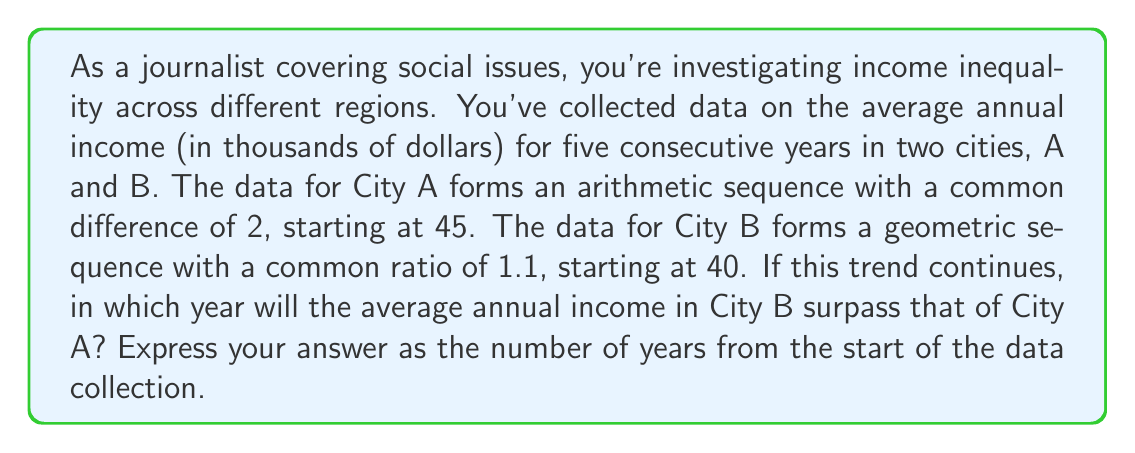Teach me how to tackle this problem. Let's approach this step-by-step:

1) For City A (arithmetic sequence):
   $a_n = a_1 + (n-1)d$, where $a_1 = 45$ and $d = 2$
   So, $a_n = 45 + (n-1)2 = 45 + 2n - 2 = 2n + 43$

2) For City B (geometric sequence):
   $b_n = a_1 \cdot r^{n-1}$, where $a_1 = 40$ and $r = 1.1$
   So, $b_n = 40 \cdot (1.1)^{n-1}$

3) We need to find when $b_n > a_n$:
   $40 \cdot (1.1)^{n-1} > 2n + 43$

4) This inequality doesn't have a straightforward algebraic solution, so we'll solve it by testing values:

   For n = 6 (year 6):
   City A: $2(6) + 43 = 55$
   City B: $40 \cdot (1.1)^5 \approx 64.46$
   64.46 > 55, so City B surpasses City A in year 6

5) Let's verify for n = 5:
   City A: $2(5) + 43 = 53$
   City B: $40 \cdot (1.1)^4 \approx 58.60$
   58.60 > 53, so City B actually surpasses City A in year 5

Therefore, City B's average annual income will surpass City A's in the 5th year from the start of data collection.
Answer: 5 years 